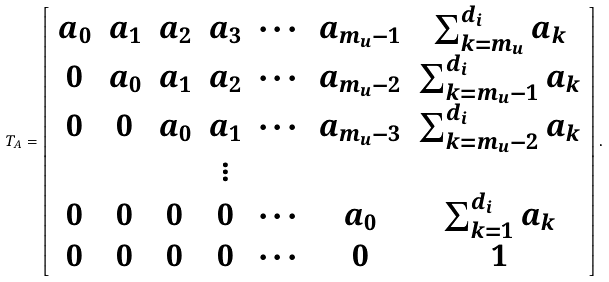<formula> <loc_0><loc_0><loc_500><loc_500>T _ { A } = \left [ \begin{array} { c c c c c c c c } a _ { 0 } & a _ { 1 } & a _ { 2 } & a _ { 3 } & \cdots & a _ { m _ { u } - 1 } & \sum _ { k = m _ { u } } ^ { d _ { i } } a _ { k } \\ 0 & a _ { 0 } & a _ { 1 } & a _ { 2 } & \cdots & a _ { m _ { u } - 2 } & \sum _ { k = m _ { u } - 1 } ^ { d _ { i } } a _ { k } \\ 0 & 0 & a _ { 0 } & a _ { 1 } & \cdots & a _ { m _ { u } - 3 } & \sum _ { k = m _ { u } - 2 } ^ { d _ { i } } a _ { k } \\ & & & \vdots & & & \\ 0 & 0 & 0 & 0 & \cdots & a _ { 0 } & \sum _ { k = 1 } ^ { d _ { i } } a _ { k } \\ 0 & 0 & 0 & 0 & \cdots & 0 & 1 \\ \end{array} \right ] .</formula> 